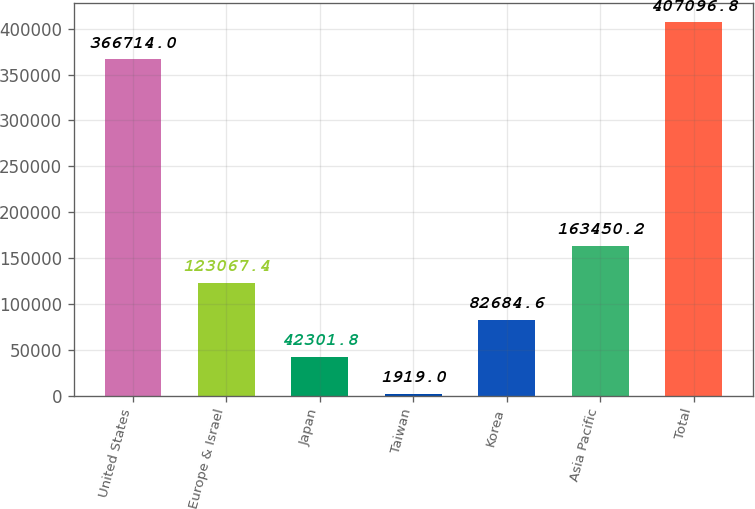<chart> <loc_0><loc_0><loc_500><loc_500><bar_chart><fcel>United States<fcel>Europe & Israel<fcel>Japan<fcel>Taiwan<fcel>Korea<fcel>Asia Pacific<fcel>Total<nl><fcel>366714<fcel>123067<fcel>42301.8<fcel>1919<fcel>82684.6<fcel>163450<fcel>407097<nl></chart> 